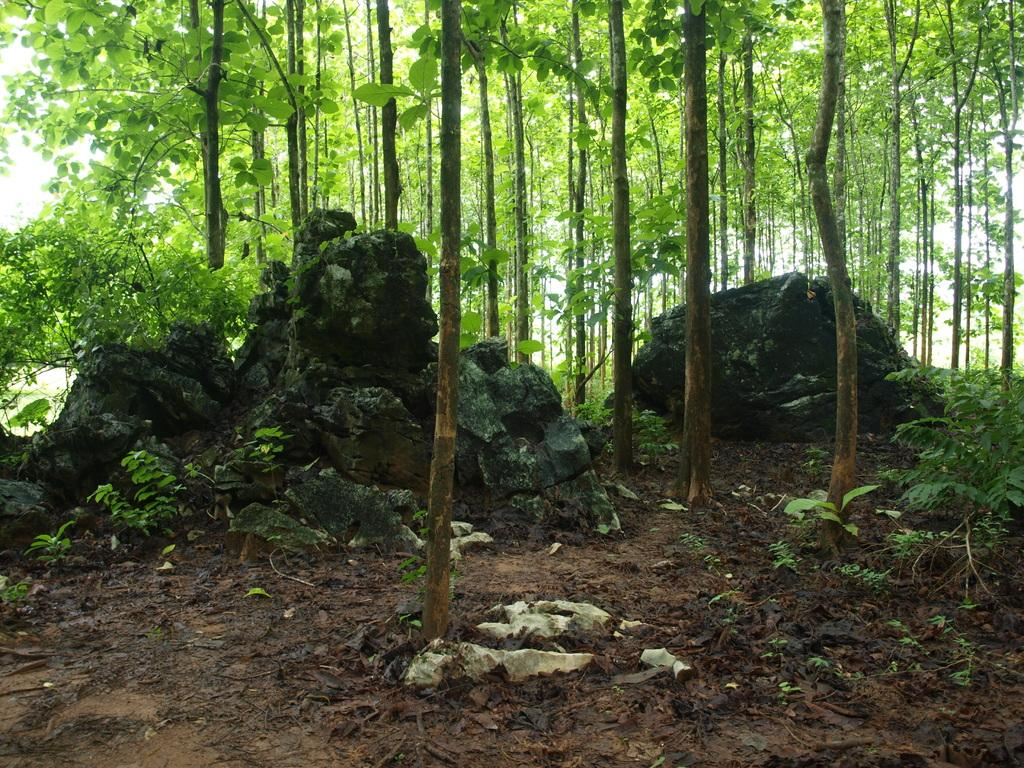What type of natural elements can be seen in the image? There are rocks, plants, and trees in the image. What might be covering the ground in the image? Leaves are present on the ground in the image. What type of cloth is draped over the car in the image? There is no car present in the image, so there is no cloth draped over it. 